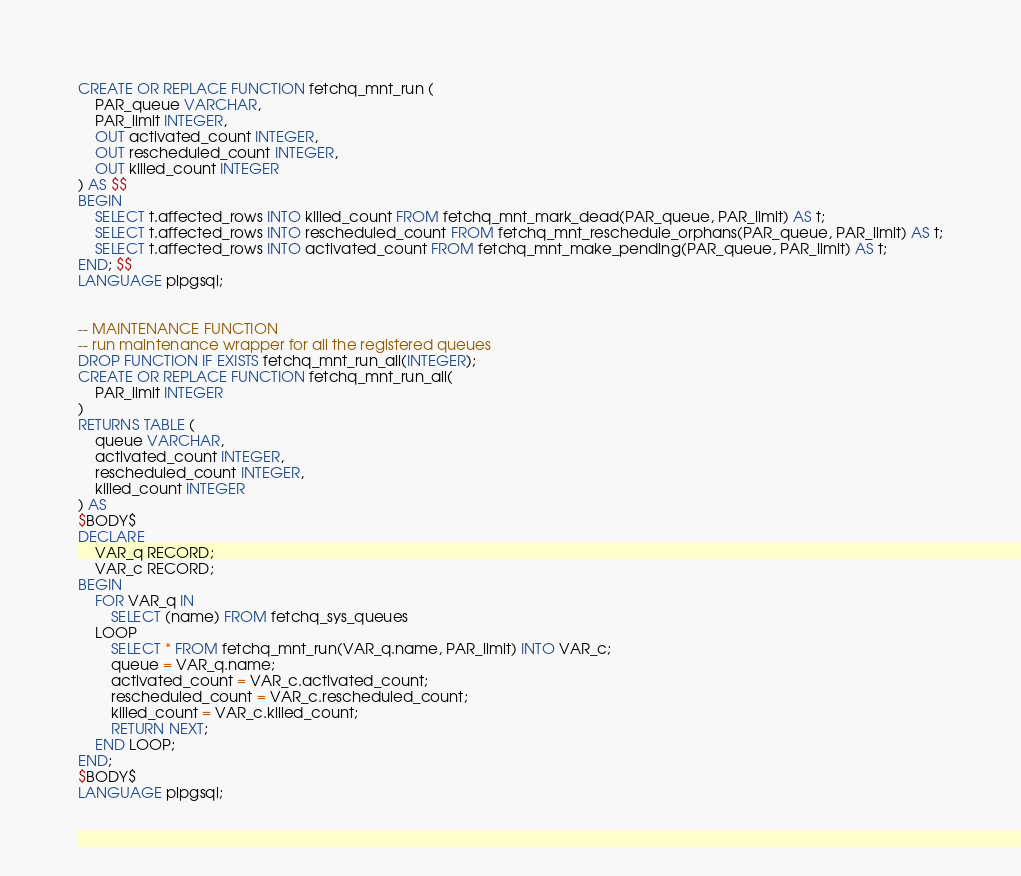Convert code to text. <code><loc_0><loc_0><loc_500><loc_500><_SQL_>CREATE OR REPLACE FUNCTION fetchq_mnt_run (
	PAR_queue VARCHAR,
	PAR_limit INTEGER,
	OUT activated_count INTEGER,
	OUT rescheduled_count INTEGER,
	OUT killed_count INTEGER
) AS $$
BEGIN
	SELECT t.affected_rows INTO killed_count FROM fetchq_mnt_mark_dead(PAR_queue, PAR_limit) AS t;
	SELECT t.affected_rows INTO rescheduled_count FROM fetchq_mnt_reschedule_orphans(PAR_queue, PAR_limit) AS t;
	SELECT t.affected_rows INTO activated_count FROM fetchq_mnt_make_pending(PAR_queue, PAR_limit) AS t;
END; $$
LANGUAGE plpgsql;


-- MAINTENANCE FUNCTION
-- run maintenance wrapper for all the registered queues
DROP FUNCTION IF EXISTS fetchq_mnt_run_all(INTEGER);
CREATE OR REPLACE FUNCTION fetchq_mnt_run_all(
	PAR_limit INTEGER
) 
RETURNS TABLE (
	queue VARCHAR,
	activated_count INTEGER,
	rescheduled_count INTEGER,
	killed_count INTEGER
) AS
$BODY$
DECLARE
	VAR_q RECORD;
	VAR_c RECORD;
BEGIN
	FOR VAR_q IN
		SELECT (name) FROM fetchq_sys_queues
	LOOP
		SELECT * FROM fetchq_mnt_run(VAR_q.name, PAR_limit) INTO VAR_c;
		queue = VAR_q.name;
		activated_count = VAR_c.activated_count;
		rescheduled_count = VAR_c.rescheduled_count;
		killed_count = VAR_c.killed_count;
		RETURN NEXT;
	END LOOP;
END;
$BODY$
LANGUAGE plpgsql;
</code> 